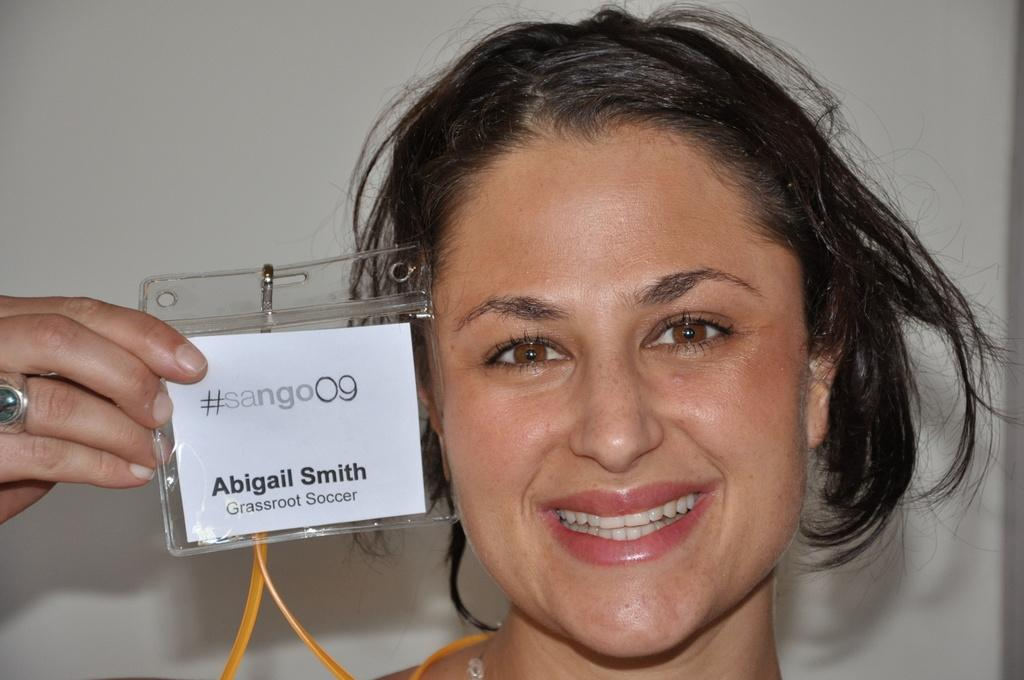Who is present in the image? There is a woman in the image. What is the woman holding in her hand? The woman is holding an identity card in her hand. What is the color of the background in the image? The background of the image is white. What type of disease can be seen on the woman's face in the image? There is no disease visible on the woman's face in the image. What is the woman using to transport the crate in the image? There is no crate present in the image. 